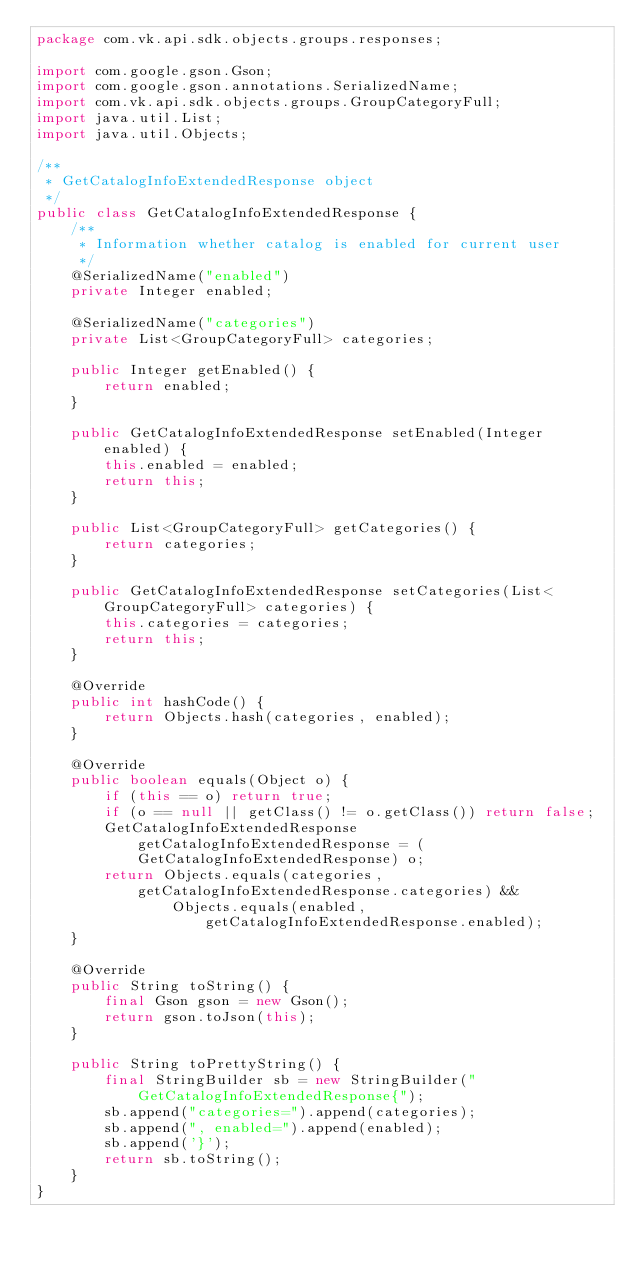Convert code to text. <code><loc_0><loc_0><loc_500><loc_500><_Java_>package com.vk.api.sdk.objects.groups.responses;

import com.google.gson.Gson;
import com.google.gson.annotations.SerializedName;
import com.vk.api.sdk.objects.groups.GroupCategoryFull;
import java.util.List;
import java.util.Objects;

/**
 * GetCatalogInfoExtendedResponse object
 */
public class GetCatalogInfoExtendedResponse {
    /**
     * Information whether catalog is enabled for current user
     */
    @SerializedName("enabled")
    private Integer enabled;

    @SerializedName("categories")
    private List<GroupCategoryFull> categories;

    public Integer getEnabled() {
        return enabled;
    }

    public GetCatalogInfoExtendedResponse setEnabled(Integer enabled) {
        this.enabled = enabled;
        return this;
    }

    public List<GroupCategoryFull> getCategories() {
        return categories;
    }

    public GetCatalogInfoExtendedResponse setCategories(List<GroupCategoryFull> categories) {
        this.categories = categories;
        return this;
    }

    @Override
    public int hashCode() {
        return Objects.hash(categories, enabled);
    }

    @Override
    public boolean equals(Object o) {
        if (this == o) return true;
        if (o == null || getClass() != o.getClass()) return false;
        GetCatalogInfoExtendedResponse getCatalogInfoExtendedResponse = (GetCatalogInfoExtendedResponse) o;
        return Objects.equals(categories, getCatalogInfoExtendedResponse.categories) &&
                Objects.equals(enabled, getCatalogInfoExtendedResponse.enabled);
    }

    @Override
    public String toString() {
        final Gson gson = new Gson();
        return gson.toJson(this);
    }

    public String toPrettyString() {
        final StringBuilder sb = new StringBuilder("GetCatalogInfoExtendedResponse{");
        sb.append("categories=").append(categories);
        sb.append(", enabled=").append(enabled);
        sb.append('}');
        return sb.toString();
    }
}
</code> 